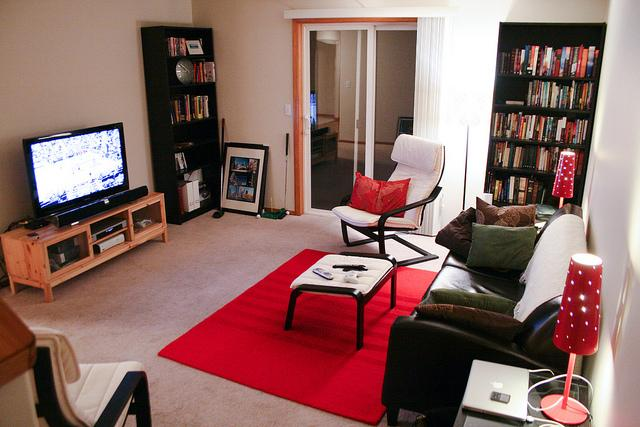What is the black couch against the wall made out of?

Choices:
A) wool
B) denim
C) nylon
D) leather leather 